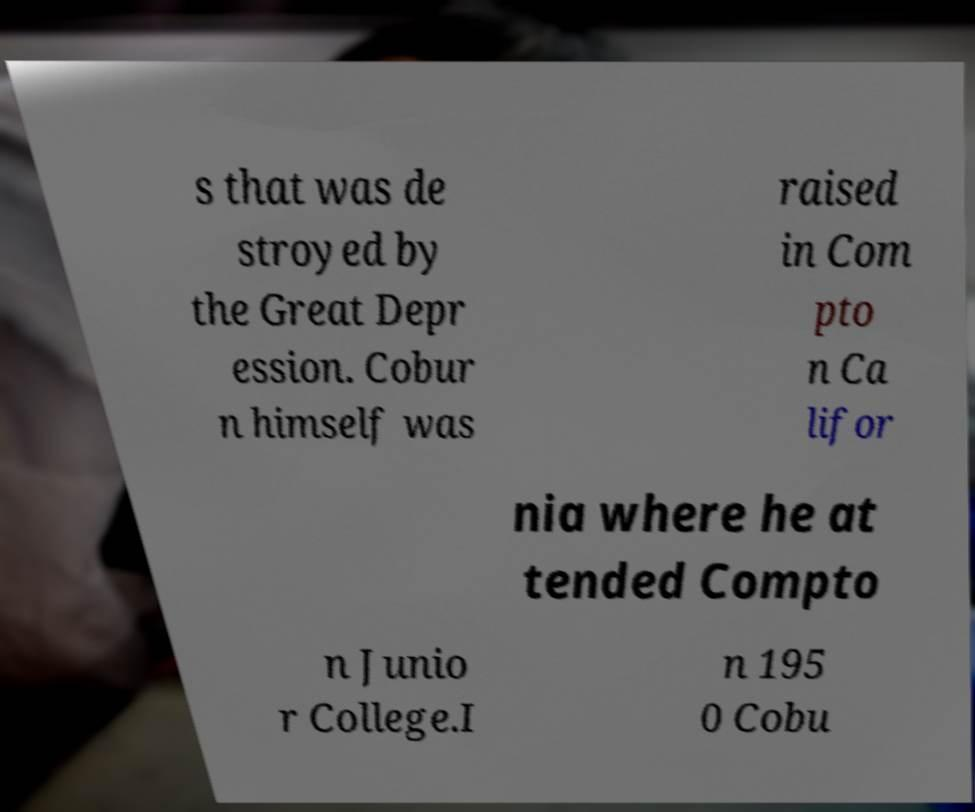Can you accurately transcribe the text from the provided image for me? s that was de stroyed by the Great Depr ession. Cobur n himself was raised in Com pto n Ca lifor nia where he at tended Compto n Junio r College.I n 195 0 Cobu 